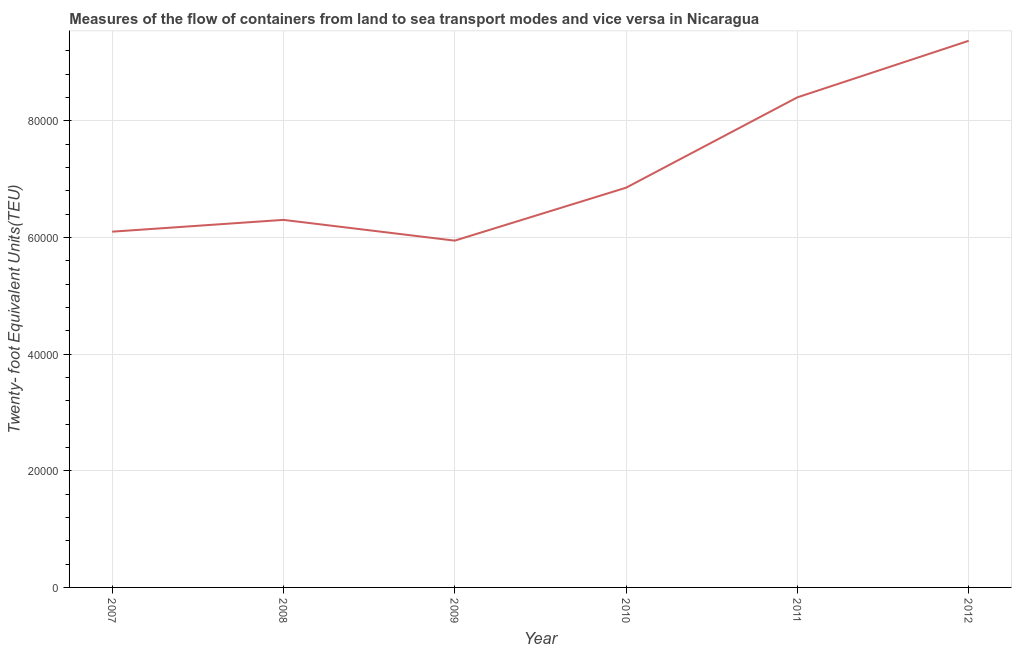What is the container port traffic in 2010?
Your response must be concise. 6.85e+04. Across all years, what is the maximum container port traffic?
Offer a terse response. 9.37e+04. Across all years, what is the minimum container port traffic?
Keep it short and to the point. 5.95e+04. What is the sum of the container port traffic?
Ensure brevity in your answer.  4.30e+05. What is the difference between the container port traffic in 2009 and 2010?
Your answer should be very brief. -9074.2. What is the average container port traffic per year?
Provide a succinct answer. 7.16e+04. What is the median container port traffic?
Your answer should be compact. 6.58e+04. In how many years, is the container port traffic greater than 24000 TEU?
Keep it short and to the point. 6. What is the ratio of the container port traffic in 2007 to that in 2011?
Your response must be concise. 0.73. Is the difference between the container port traffic in 2011 and 2012 greater than the difference between any two years?
Ensure brevity in your answer.  No. What is the difference between the highest and the second highest container port traffic?
Offer a very short reply. 9695.63. What is the difference between the highest and the lowest container port traffic?
Your answer should be very brief. 3.43e+04. In how many years, is the container port traffic greater than the average container port traffic taken over all years?
Keep it short and to the point. 2. How many lines are there?
Offer a terse response. 1. How many years are there in the graph?
Offer a very short reply. 6. What is the difference between two consecutive major ticks on the Y-axis?
Ensure brevity in your answer.  2.00e+04. Are the values on the major ticks of Y-axis written in scientific E-notation?
Offer a very short reply. No. What is the title of the graph?
Offer a very short reply. Measures of the flow of containers from land to sea transport modes and vice versa in Nicaragua. What is the label or title of the Y-axis?
Give a very brief answer. Twenty- foot Equivalent Units(TEU). What is the Twenty- foot Equivalent Units(TEU) in 2007?
Offer a terse response. 6.10e+04. What is the Twenty- foot Equivalent Units(TEU) in 2008?
Your response must be concise. 6.30e+04. What is the Twenty- foot Equivalent Units(TEU) in 2009?
Keep it short and to the point. 5.95e+04. What is the Twenty- foot Equivalent Units(TEU) of 2010?
Offer a very short reply. 6.85e+04. What is the Twenty- foot Equivalent Units(TEU) in 2011?
Provide a succinct answer. 8.40e+04. What is the Twenty- foot Equivalent Units(TEU) in 2012?
Your answer should be compact. 9.37e+04. What is the difference between the Twenty- foot Equivalent Units(TEU) in 2007 and 2008?
Offer a very short reply. -2023. What is the difference between the Twenty- foot Equivalent Units(TEU) in 2007 and 2009?
Make the answer very short. 1536. What is the difference between the Twenty- foot Equivalent Units(TEU) in 2007 and 2010?
Provide a succinct answer. -7538.2. What is the difference between the Twenty- foot Equivalent Units(TEU) in 2007 and 2011?
Keep it short and to the point. -2.30e+04. What is the difference between the Twenty- foot Equivalent Units(TEU) in 2007 and 2012?
Make the answer very short. -3.27e+04. What is the difference between the Twenty- foot Equivalent Units(TEU) in 2008 and 2009?
Your answer should be very brief. 3559. What is the difference between the Twenty- foot Equivalent Units(TEU) in 2008 and 2010?
Provide a short and direct response. -5515.2. What is the difference between the Twenty- foot Equivalent Units(TEU) in 2008 and 2011?
Your answer should be very brief. -2.10e+04. What is the difference between the Twenty- foot Equivalent Units(TEU) in 2008 and 2012?
Ensure brevity in your answer.  -3.07e+04. What is the difference between the Twenty- foot Equivalent Units(TEU) in 2009 and 2010?
Your answer should be very brief. -9074.2. What is the difference between the Twenty- foot Equivalent Units(TEU) in 2009 and 2011?
Give a very brief answer. -2.46e+04. What is the difference between the Twenty- foot Equivalent Units(TEU) in 2009 and 2012?
Offer a very short reply. -3.43e+04. What is the difference between the Twenty- foot Equivalent Units(TEU) in 2010 and 2011?
Offer a terse response. -1.55e+04. What is the difference between the Twenty- foot Equivalent Units(TEU) in 2010 and 2012?
Provide a succinct answer. -2.52e+04. What is the difference between the Twenty- foot Equivalent Units(TEU) in 2011 and 2012?
Give a very brief answer. -9695.63. What is the ratio of the Twenty- foot Equivalent Units(TEU) in 2007 to that in 2008?
Ensure brevity in your answer.  0.97. What is the ratio of the Twenty- foot Equivalent Units(TEU) in 2007 to that in 2009?
Keep it short and to the point. 1.03. What is the ratio of the Twenty- foot Equivalent Units(TEU) in 2007 to that in 2010?
Offer a terse response. 0.89. What is the ratio of the Twenty- foot Equivalent Units(TEU) in 2007 to that in 2011?
Your answer should be very brief. 0.73. What is the ratio of the Twenty- foot Equivalent Units(TEU) in 2007 to that in 2012?
Provide a succinct answer. 0.65. What is the ratio of the Twenty- foot Equivalent Units(TEU) in 2008 to that in 2009?
Your answer should be very brief. 1.06. What is the ratio of the Twenty- foot Equivalent Units(TEU) in 2008 to that in 2010?
Provide a short and direct response. 0.92. What is the ratio of the Twenty- foot Equivalent Units(TEU) in 2008 to that in 2012?
Offer a terse response. 0.67. What is the ratio of the Twenty- foot Equivalent Units(TEU) in 2009 to that in 2010?
Make the answer very short. 0.87. What is the ratio of the Twenty- foot Equivalent Units(TEU) in 2009 to that in 2011?
Keep it short and to the point. 0.71. What is the ratio of the Twenty- foot Equivalent Units(TEU) in 2009 to that in 2012?
Offer a very short reply. 0.63. What is the ratio of the Twenty- foot Equivalent Units(TEU) in 2010 to that in 2011?
Provide a succinct answer. 0.82. What is the ratio of the Twenty- foot Equivalent Units(TEU) in 2010 to that in 2012?
Keep it short and to the point. 0.73. What is the ratio of the Twenty- foot Equivalent Units(TEU) in 2011 to that in 2012?
Make the answer very short. 0.9. 